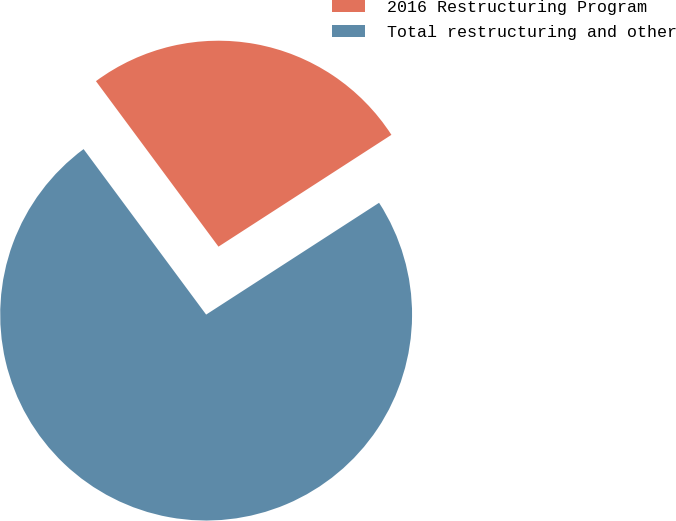Convert chart to OTSL. <chart><loc_0><loc_0><loc_500><loc_500><pie_chart><fcel>2016 Restructuring Program<fcel>Total restructuring and other<nl><fcel>26.01%<fcel>73.99%<nl></chart> 